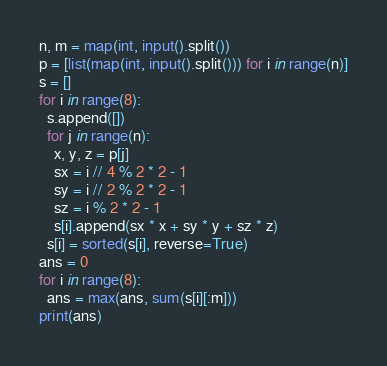<code> <loc_0><loc_0><loc_500><loc_500><_Python_>n, m = map(int, input().split())
p = [list(map(int, input().split())) for i in range(n)]
s = []
for i in range(8):
  s.append([])
  for j in range(n):
    x, y, z = p[j]
    sx = i // 4 % 2 * 2 - 1
    sy = i // 2 % 2 * 2 - 1
    sz = i % 2 * 2 - 1
    s[i].append(sx * x + sy * y + sz * z)
  s[i] = sorted(s[i], reverse=True)
ans = 0
for i in range(8):
  ans = max(ans, sum(s[i][:m]))
print(ans)
</code> 